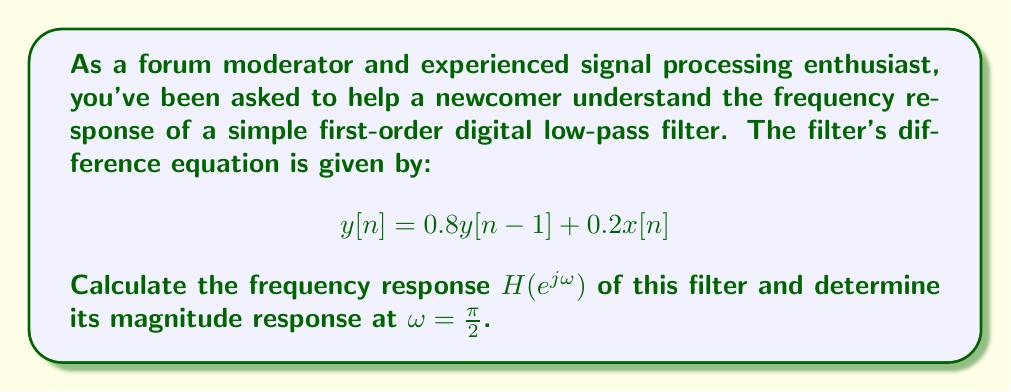Teach me how to tackle this problem. To calculate the frequency response of a digital filter, we follow these steps:

1) First, we take the z-transform of the difference equation:
   
   $Y(z) = 0.8Y(z)z^{-1} + 0.2X(z)$

2) Rearrange to get the transfer function $H(z) = \frac{Y(z)}{X(z)}$:
   
   $Y(z) - 0.8Y(z)z^{-1} = 0.2X(z)$
   $Y(z)(1 - 0.8z^{-1}) = 0.2X(z)$
   
   $$H(z) = \frac{Y(z)}{X(z)} = \frac{0.2}{1 - 0.8z^{-1}}$$

3) To get the frequency response, we substitute $z = e^{j\omega}$:
   
   $$H(e^{j\omega}) = \frac{0.2}{1 - 0.8e^{-j\omega}}$$

4) To calculate the magnitude response at $\omega = \frac{\pi}{2}$, we substitute this value:
   
   $$H(e^{j\frac{\pi}{2}}) = \frac{0.2}{1 - 0.8e^{-j\frac{\pi}{2}}}$$

5) Recall that $e^{-j\frac{\pi}{2}} = -j$, so:
   
   $$H(e^{j\frac{\pi}{2}}) = \frac{0.2}{1 - 0.8(-j)} = \frac{0.2}{1 + 0.8j}$$

6) To find the magnitude, we calculate the absolute value:
   
   $$|H(e^{j\frac{\pi}{2}})| = \left|\frac{0.2}{1 + 0.8j}\right| = \frac{0.2}{\sqrt{1^2 + 0.8^2}} = \frac{0.2}{\sqrt{1.64}} \approx 0.1562$$
Answer: The frequency response of the filter is:

$$H(e^{j\omega}) = \frac{0.2}{1 - 0.8e^{-j\omega}}$$

The magnitude response at $\omega = \frac{\pi}{2}$ is approximately 0.1562. 